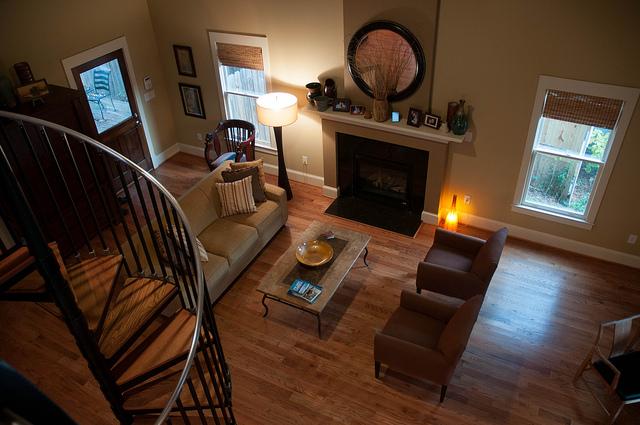What room is this?
Quick response, please. Living room. How many pillows are on the furniture, excluding the ones that are part of the furniture?
Concise answer only. 4. Are all the lights on?
Be succinct. Yes. What viewpoint was this picture taken?
Quick response, please. Above. Is it sunny outside of this room?
Concise answer only. Yes. 